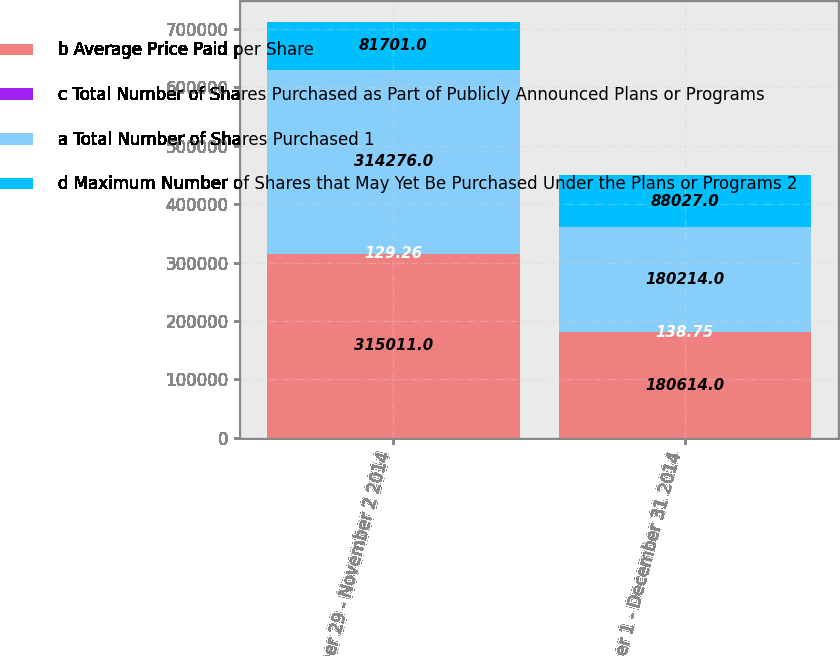<chart> <loc_0><loc_0><loc_500><loc_500><stacked_bar_chart><ecel><fcel>September 29 - November 2 2014<fcel>December 1 - December 31 2014<nl><fcel>b Average Price Paid per Share<fcel>315011<fcel>180614<nl><fcel>c Total Number of Shares Purchased as Part of Publicly Announced Plans or Programs<fcel>129.26<fcel>138.75<nl><fcel>a Total Number of Shares Purchased 1<fcel>314276<fcel>180214<nl><fcel>d Maximum Number of Shares that May Yet Be Purchased Under the Plans or Programs 2<fcel>81701<fcel>88027<nl></chart> 